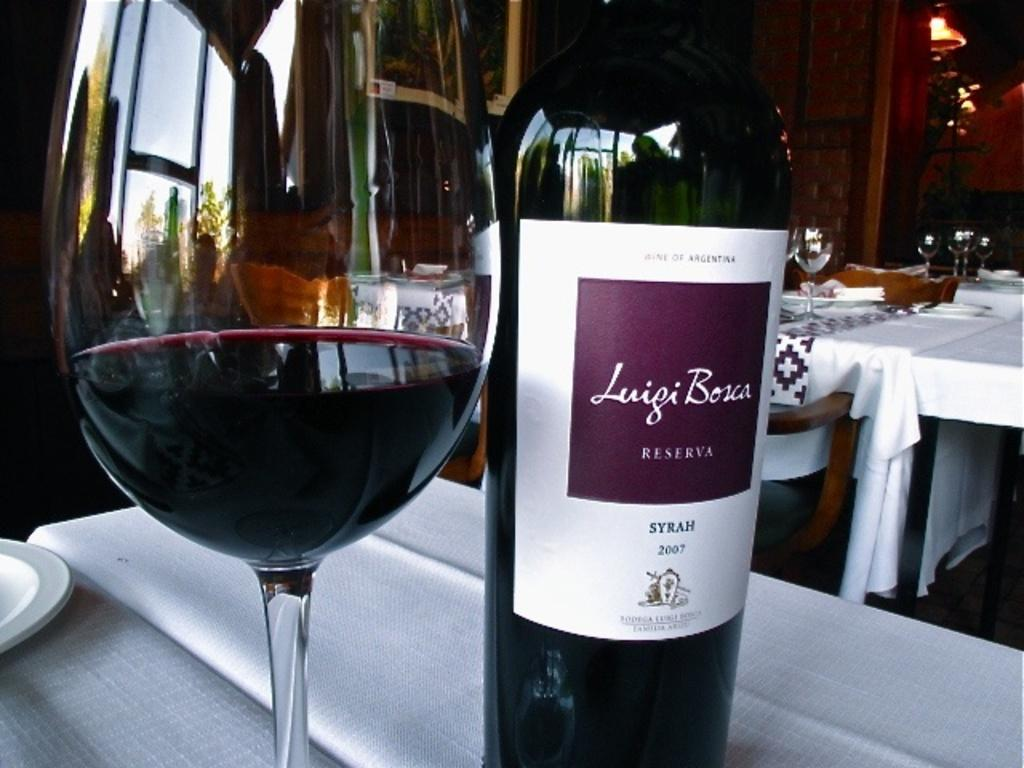<image>
Describe the image concisely. the name Luigi is written on some wine bottles 